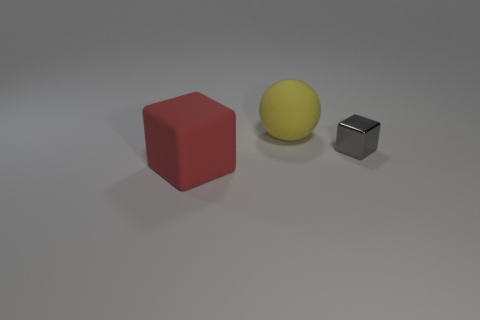Add 1 cyan balls. How many objects exist? 4 Subtract all gray blocks. How many blocks are left? 1 Subtract all cyan cylinders. How many red blocks are left? 1 Subtract all big cubes. Subtract all large blocks. How many objects are left? 1 Add 1 big yellow objects. How many big yellow objects are left? 2 Add 2 big shiny balls. How many big shiny balls exist? 2 Subtract 1 red cubes. How many objects are left? 2 Subtract all blocks. How many objects are left? 1 Subtract all red cubes. Subtract all green spheres. How many cubes are left? 1 